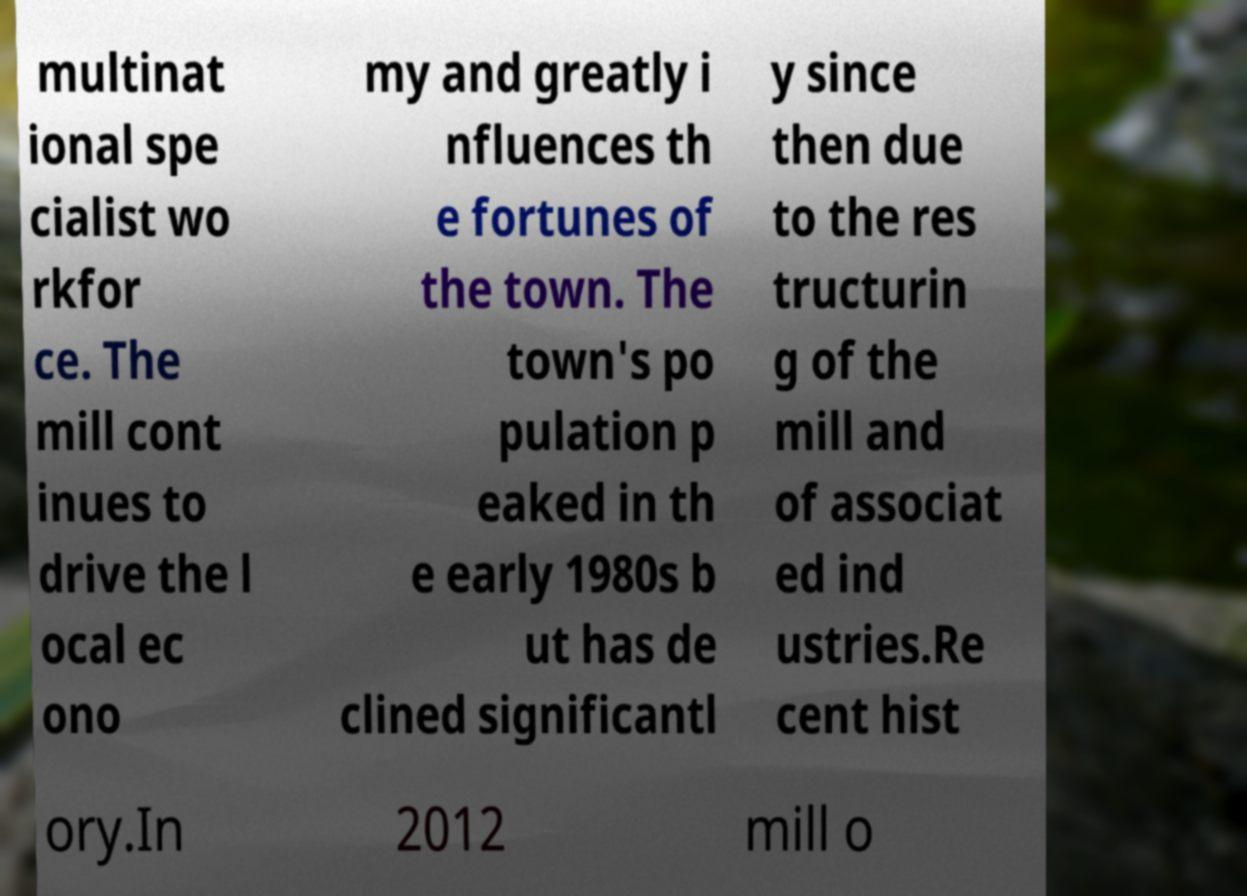Could you assist in decoding the text presented in this image and type it out clearly? multinat ional spe cialist wo rkfor ce. The mill cont inues to drive the l ocal ec ono my and greatly i nfluences th e fortunes of the town. The town's po pulation p eaked in th e early 1980s b ut has de clined significantl y since then due to the res tructurin g of the mill and of associat ed ind ustries.Re cent hist ory.In 2012 mill o 